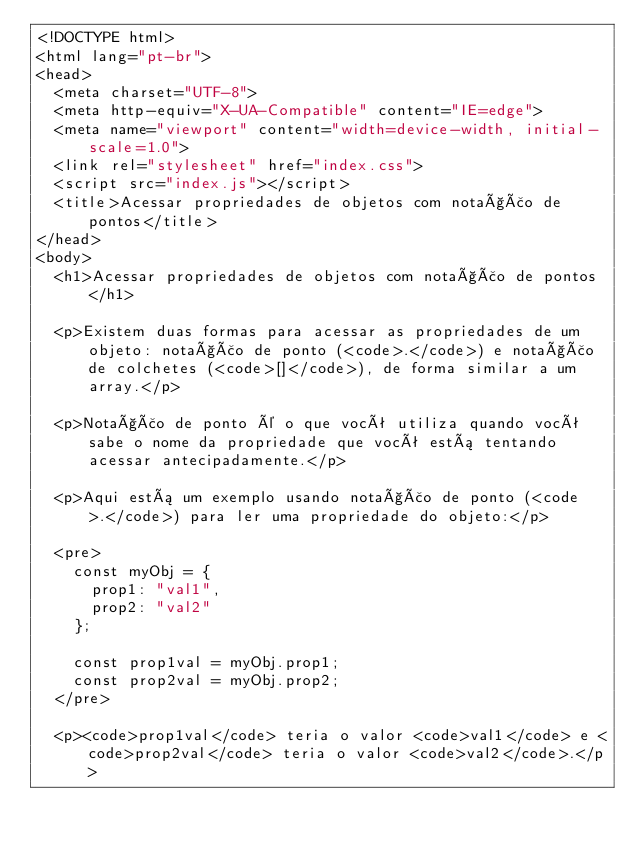Convert code to text. <code><loc_0><loc_0><loc_500><loc_500><_HTML_><!DOCTYPE html>
<html lang="pt-br">
<head>
  <meta charset="UTF-8">
  <meta http-equiv="X-UA-Compatible" content="IE=edge">
  <meta name="viewport" content="width=device-width, initial-scale=1.0">
  <link rel="stylesheet" href="index.css">
  <script src="index.js"></script>
  <title>Acessar propriedades de objetos com notação de pontos</title>
</head>
<body>
  <h1>Acessar propriedades de objetos com notação de pontos</h1>

  <p>Existem duas formas para acessar as propriedades de um objeto: notação de ponto (<code>.</code>) e notação de colchetes (<code>[]</code>), de forma similar a um array.</p>

  <p>Notação de ponto é o que você utiliza quando você sabe o nome da propriedade que você está tentando acessar antecipadamente.</p>

  <p>Aqui está um exemplo usando notação de ponto (<code>.</code>) para ler uma propriedade do objeto:</p>

  <pre>
    const myObj = {
      prop1: "val1",
      prop2: "val2"
    };

    const prop1val = myObj.prop1;
    const prop2val = myObj.prop2;
  </pre>

  <p><code>prop1val</code> teria o valor <code>val1</code> e <code>prop2val</code> teria o valor <code>val2</code>.</p>
</code> 